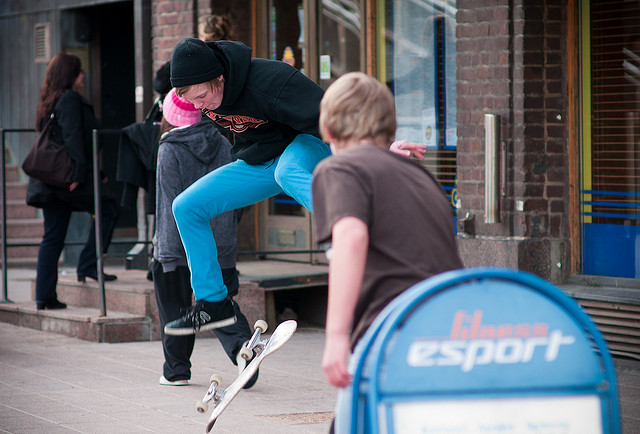Please extract the text content from this image. esport 